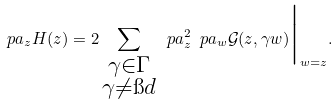<formula> <loc_0><loc_0><loc_500><loc_500>\ p a _ { z } H ( z ) = 2 \sum _ { \substack { \gamma \in \Gamma \\ \gamma \neq \i d } } \ p a ^ { 2 } _ { z } \ p a _ { w } \mathcal { G } ( z , \gamma w ) \Big | _ { w = z } .</formula> 